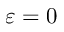Convert formula to latex. <formula><loc_0><loc_0><loc_500><loc_500>\varepsilon = 0</formula> 